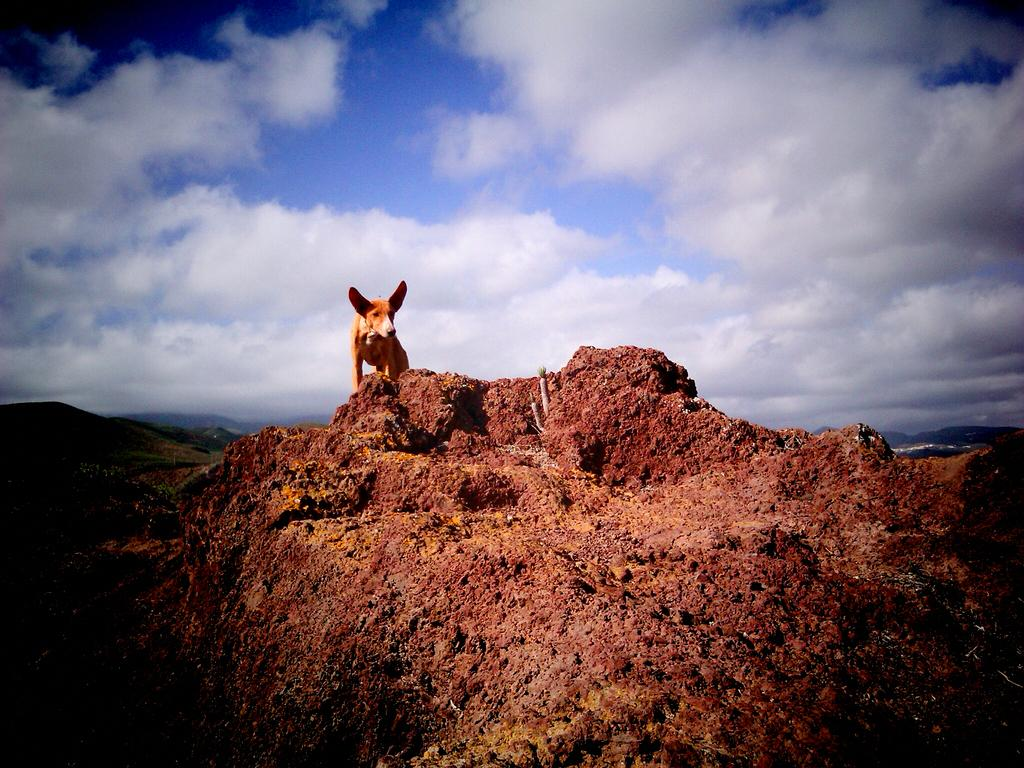What is the main subject of the image? There is a dog standing on a rock in the image. What can be seen in the background of the image? There are mountains in the background of the image. What is visible in the sky at the top of the image? There are clouds visible in the sky at the top of the image. What type of string is the dog playing with in the image? There is no string present in the image; the dog is standing on a rock. What form does the dog take in the image? The dog is in its natural form, as it is a living animal. 